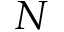Convert formula to latex. <formula><loc_0><loc_0><loc_500><loc_500>N</formula> 